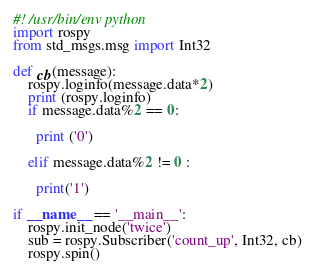<code> <loc_0><loc_0><loc_500><loc_500><_Python_>#! /usr/bin/env python
import rospy
from std_msgs.msg import Int32

def cb(message):
    rospy.loginfo(message.data*2)
    print (rospy.loginfo)
    if message.data%2 == 0:

      print ('0')

    elif message.data%2 != 0 :
      
      print('1')

if __name__ == '__main__':
    rospy.init_node('twice')
    sub = rospy.Subscriber('count_up', Int32, cb)
    rospy.spin()
</code> 